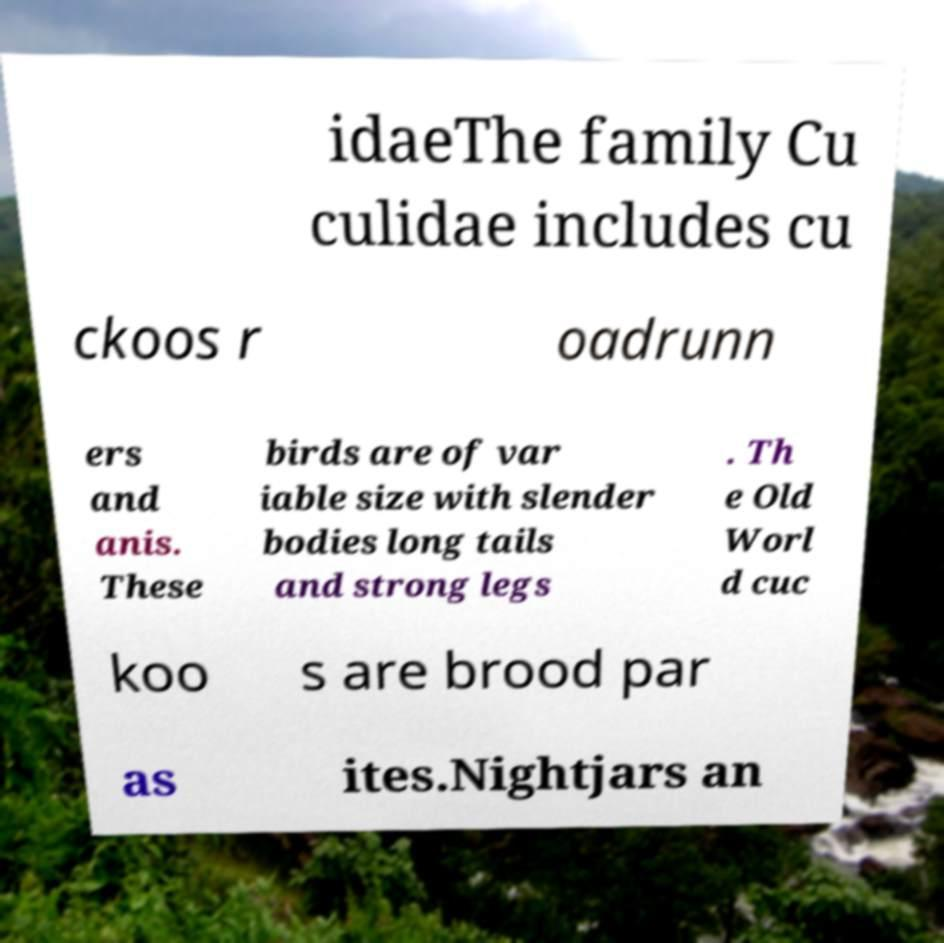Can you read and provide the text displayed in the image?This photo seems to have some interesting text. Can you extract and type it out for me? idaeThe family Cu culidae includes cu ckoos r oadrunn ers and anis. These birds are of var iable size with slender bodies long tails and strong legs . Th e Old Worl d cuc koo s are brood par as ites.Nightjars an 